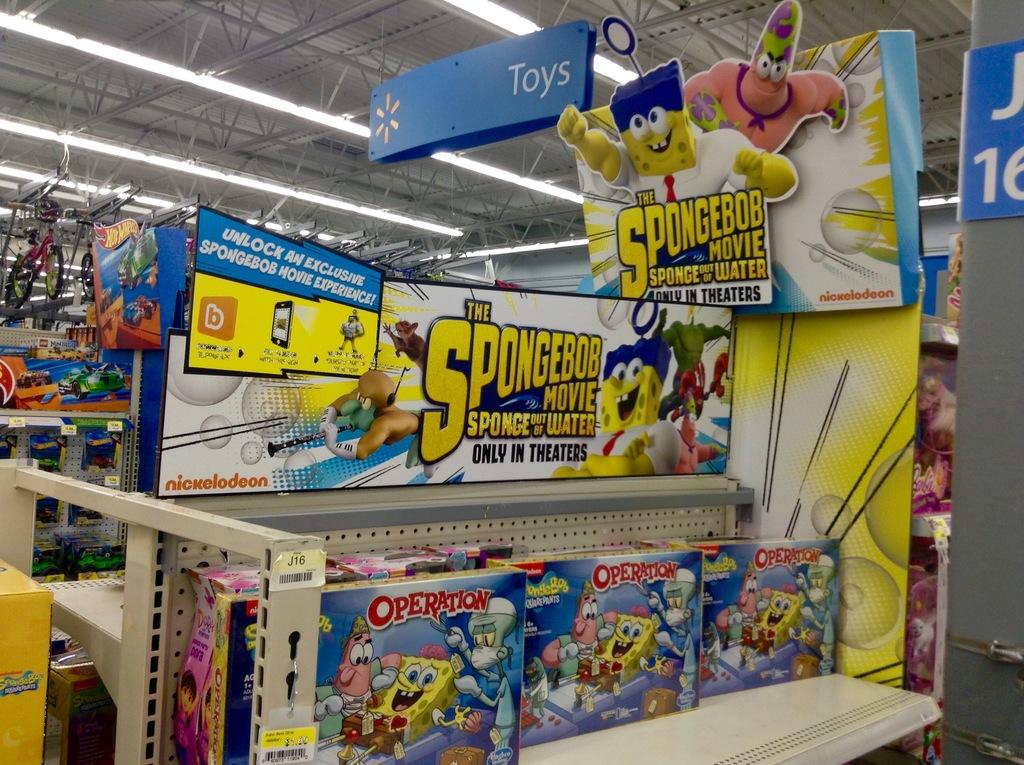Where can i watch the new spongebob movie?
Your answer should be compact. Theaters. What other product does this store sell?
Give a very brief answer. Toys. 